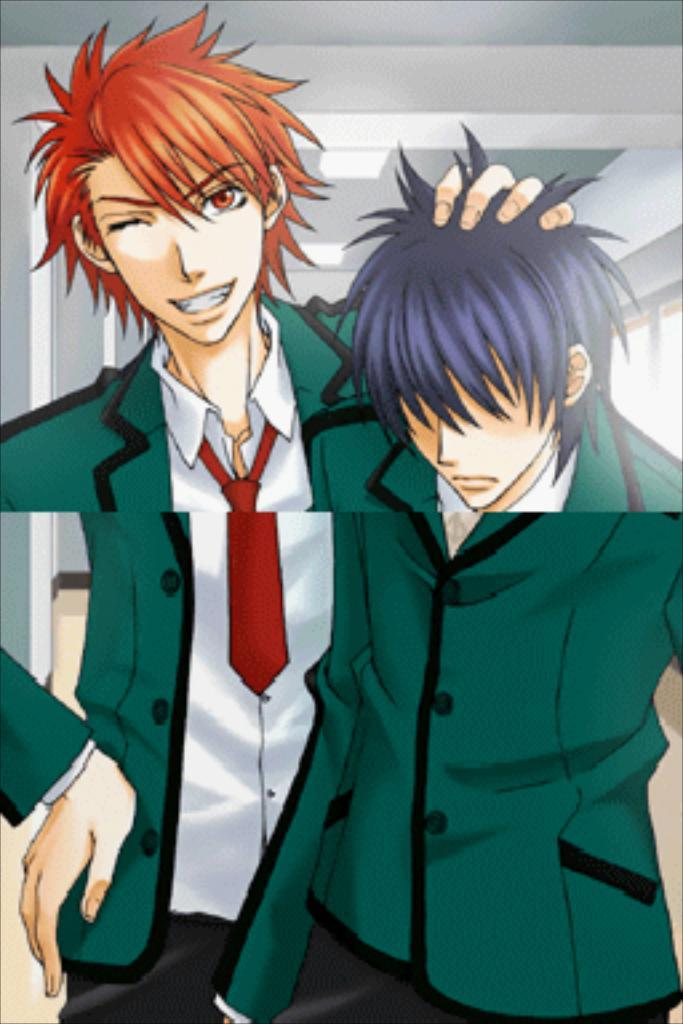What type of characters are depicted in the image? There are cartoons of people in the image. What can be seen on the right side of the image? There is a glass window on the right side of the image. What is visible at the top of the image? There are lights visible at the top of the image. What type of rock can be seen in the image? There is no rock present in the image. What is the texture of the cartoons in the image? The texture of the cartoons cannot be determined from the image alone, as it is a 2D representation. 